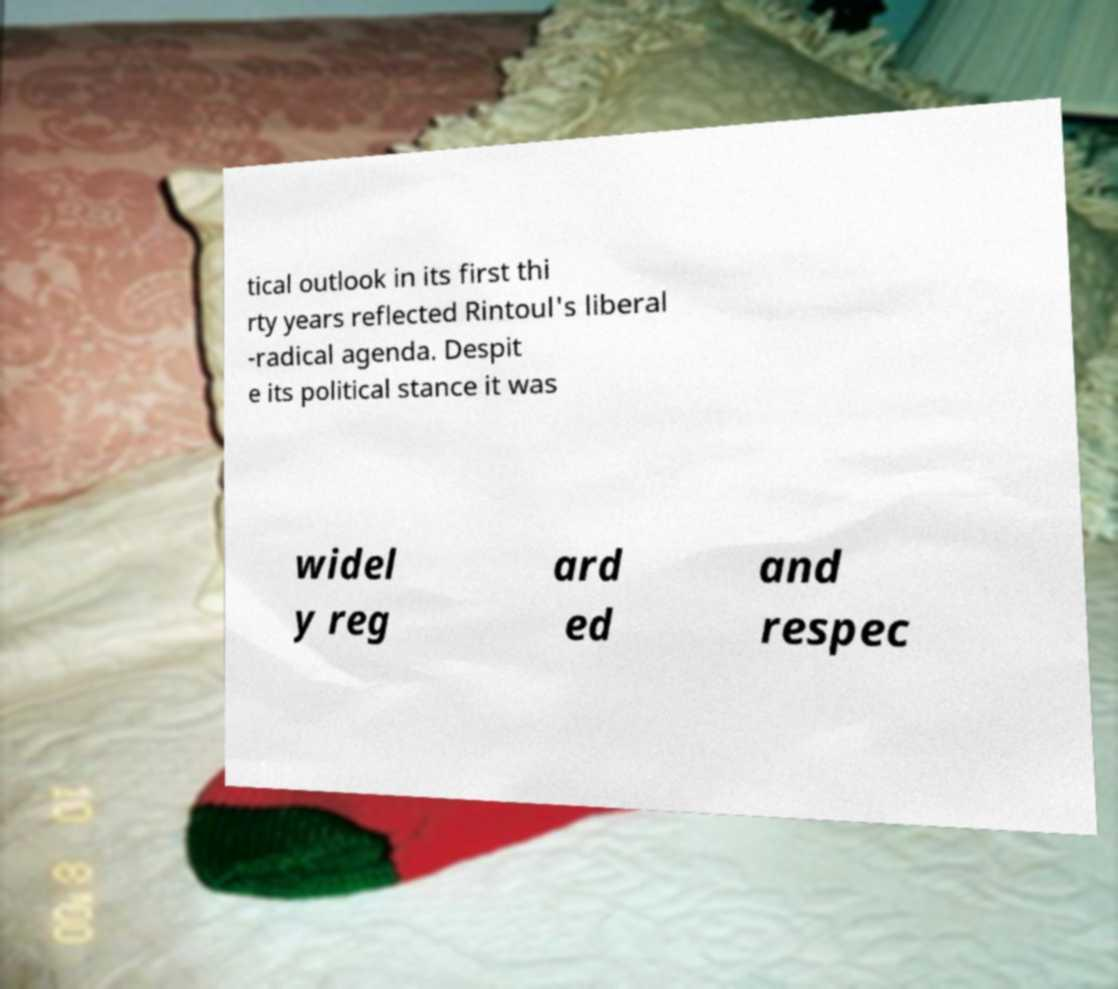I need the written content from this picture converted into text. Can you do that? tical outlook in its first thi rty years reflected Rintoul's liberal -radical agenda. Despit e its political stance it was widel y reg ard ed and respec 